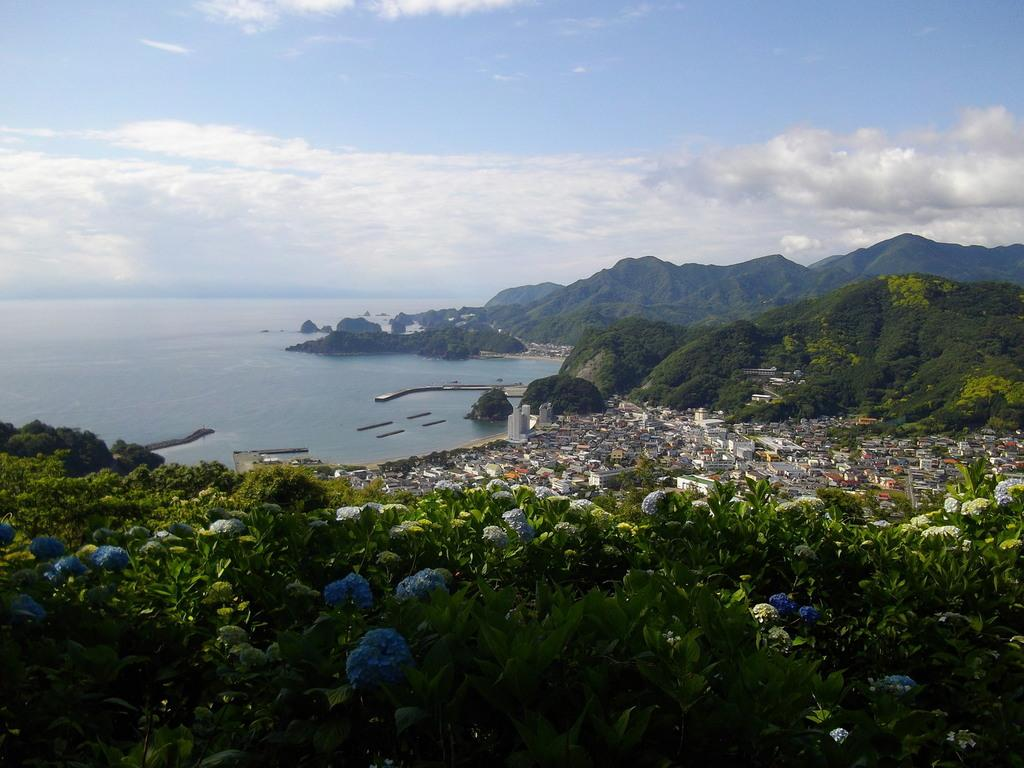What type of structures are present in the image? There are houses in the image. What other natural elements can be seen in the image? There are trees in the image. Where are the houses and trees located in the image? The houses and trees are located at the bottom side of the image. What can be seen in the background of the image? There is water visible in the background of the image. What color are the crayons used to draw the houses in the image? There are no crayons or drawings present in the image; it features actual houses and trees. 